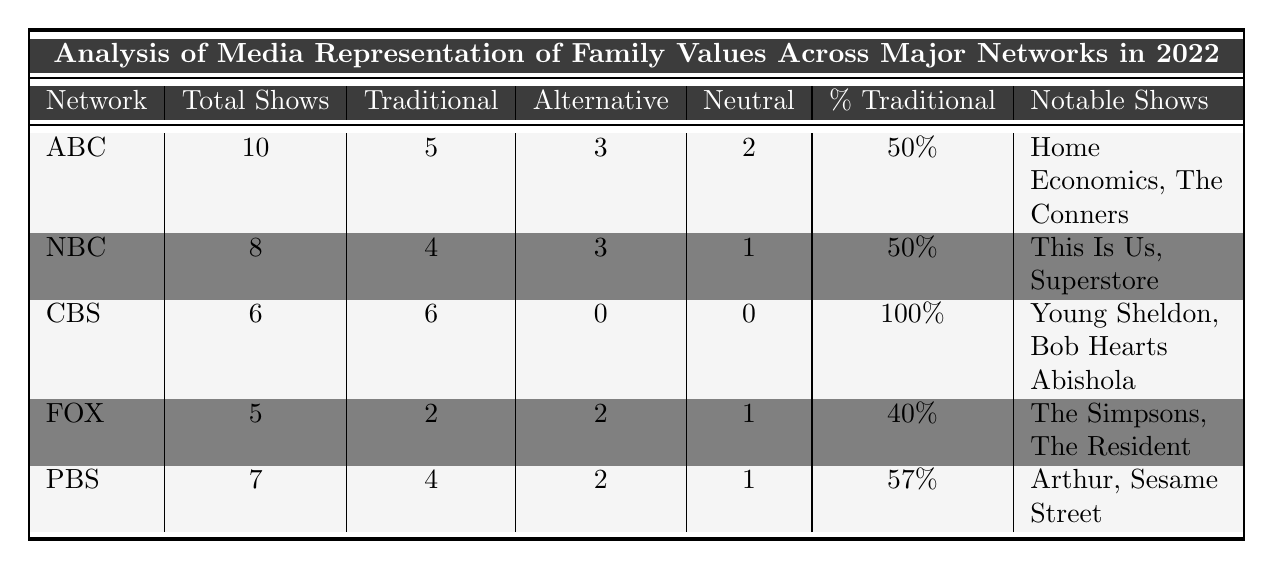What is the total number of family-oriented shows on CBS? According to the table, CBS has 6 total family-oriented shows listed.
Answer: 6 How many shows on NBC represent traditional families? The table indicates that NBC has 4 shows that portray traditional family representation.
Answer: 4 What is the percentage of traditional family shows on FOX? The table states that the percentage of traditional family shows on FOX is 40%.
Answer: 40% Which network has the highest percentage of traditional family shows? By examining the table, CBS stands out with a 100% percentage of traditional family shows, the highest among all networks.
Answer: CBS How many shows with alternative family structures does PBS have? The table shows that PBS has 2 shows featuring alternative family structures.
Answer: 2 What is the average percentage of traditional family shows across all networks listed? To find the average percentage, add the percentages: 50% + 50% + 100% + 40% + 57% = 297%. Then divide by 5 (the number of networks) to get 297% / 5 = 59.4%.
Answer: 59.4% Does ABC have more shows with traditional family representation than FOX? Yes, comparing the table, ABC has 5 shows with traditional family representation while FOX has only 2.
Answer: Yes Which network has the lowest total number of family-oriented shows? The table shows that FOX has the lowest total, with only 5 family-oriented shows.
Answer: FOX Is the number of shows with alternative family structures on NBC greater than that on PBS? No, NBC has 3 shows with alternative structures, while PBS has only 2 shows.
Answer: No What is the difference in the number of traditional family shows between CBS and ABC? CBS has 6 traditional family shows and ABC has 5. The difference is 6 - 5 = 1.
Answer: 1 